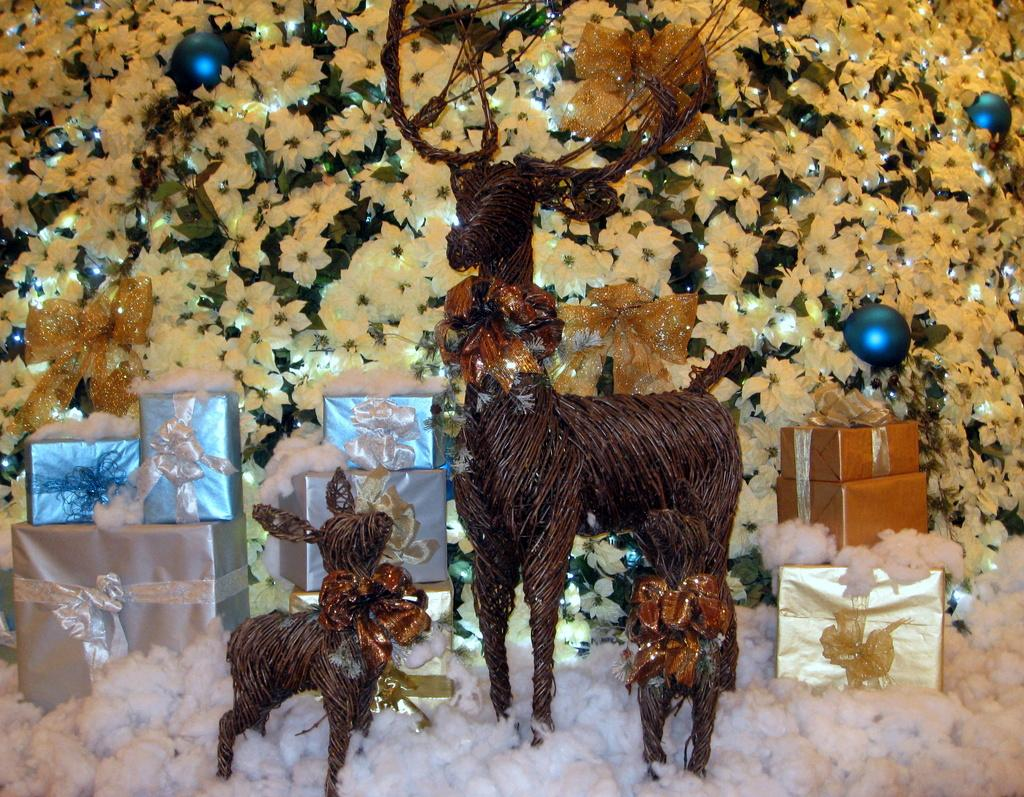What type of objects can be seen in the image? There are flowers, toys, and gift boxes in the image. Can you describe the flowers in the image? Unfortunately, the facts provided do not give specific details about the flowers. What kind of toys are present in the image? The facts provided do not specify the type of toys in the image. How many gift boxes are visible in the image? The facts provided do not mention the number of gift boxes in the image. What type of vase is holding the flowers in the image? There is no vase present in the image; the flowers are not specified as being in a vase. Can you describe the rock formation near the toys in the image? There is no rock formation mentioned in the image; the facts provided only mention toys and flowers. 